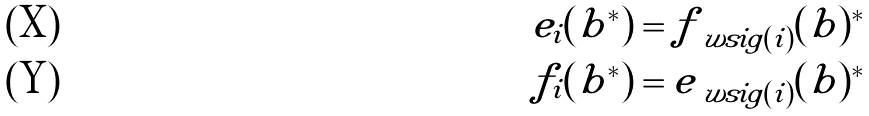<formula> <loc_0><loc_0><loc_500><loc_500>e _ { i } ( b ^ { * } ) & = f _ { \ w s i g ( i ) } ( b ) ^ { * } \\ f _ { i } ( b ^ { * } ) & = e _ { \ w s i g ( i ) } ( b ) ^ { * }</formula> 